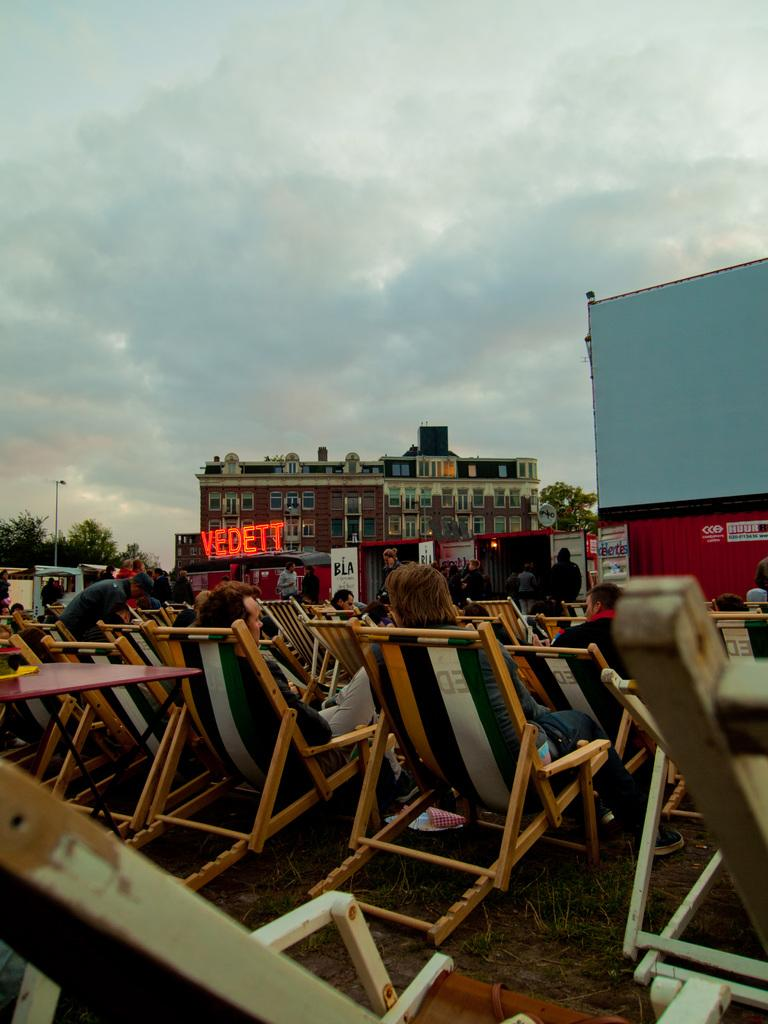What are the persons in the image doing? The persons in the image are sitting on chairs. What type of structure can be seen in the image? There is a building in the image. What object is present in the image that might be used for displaying information or announcements? There is a board in the image. What type of natural vegetation is visible in the image? There are trees in the image. What type of vertical structure can be seen in the image? There is a pole in the image. What is visible in the background of the image? The sky is visible in the image, and clouds are present in the sky. What is the profit of the playground in the image? There is no playground present in the image, so it is not possible to determine its profit. What hobbies do the persons sitting on chairs in the image enjoy? There is no information about the persons' hobbies in the image. 